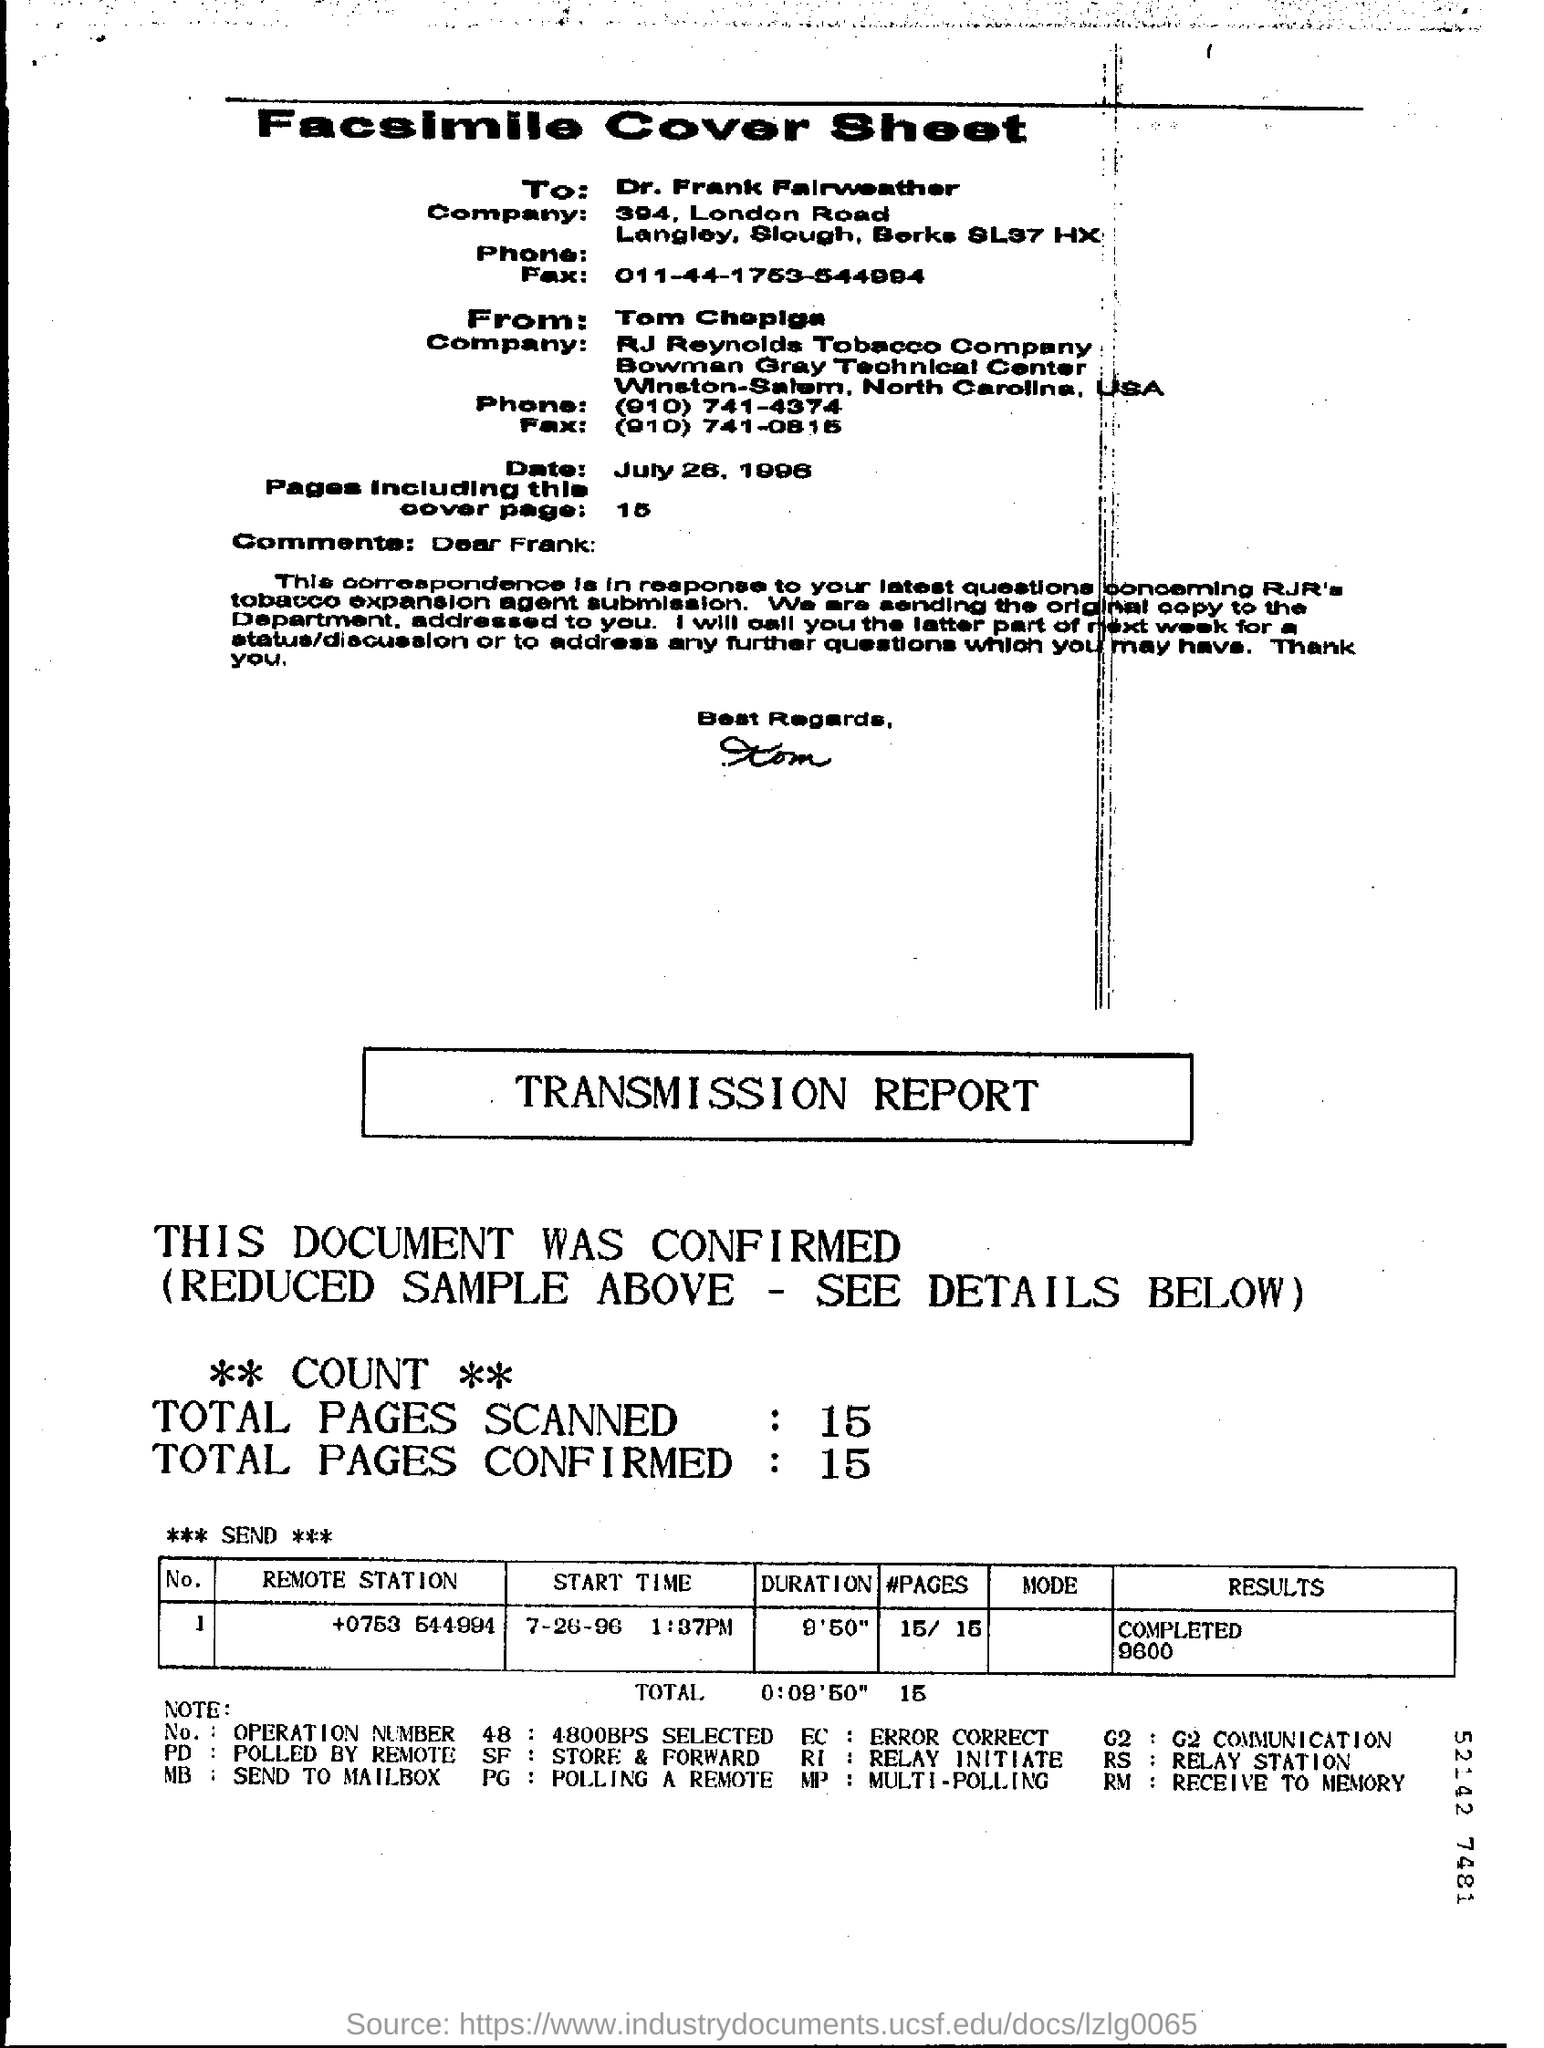Who is the addressee?
Keep it short and to the point. Dr. Frank Falrweather. What is the 'Fax' number given in 'To' address part?
Provide a short and direct response. 011-44-1753-544994. How many pages are mentioned in the Cover sheet ?
Your answer should be very brief. 15. What is the COUNT of TOTAL SCANNED PAGES in TRANSMISSION REPORT ?
Offer a very short reply. 15. What is the total duration marked in TRANSMISSION REPORT ?
Provide a succinct answer. 0:09'50". What is the 'START TIME' of sending the pages based on the table entry?
Your answer should be compact. 1:37pm. What 'pd' denotes based on the 'note' given at the bottom of the page?
Give a very brief answer. Polled by remote. What 'RI' denotes based on the 'NOTE' given at the bottom of the page?
Give a very brief answer. RELAY INITIATE. 